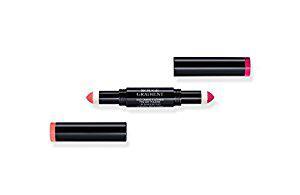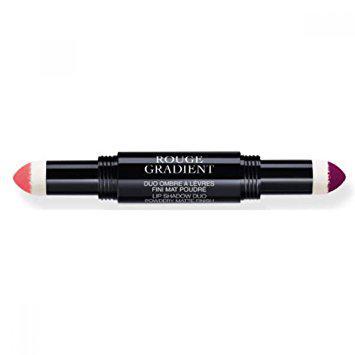The first image is the image on the left, the second image is the image on the right. Evaluate the accuracy of this statement regarding the images: "Each image includes an unlidded double-sided lip makeup with a marker-type tip on each end of a stick.". Is it true? Answer yes or no. Yes. The first image is the image on the left, the second image is the image on the right. Evaluate the accuracy of this statement regarding the images: "The makeup in the left image is photographed against a pure white background with no decoration on it.". Is it true? Answer yes or no. Yes. 